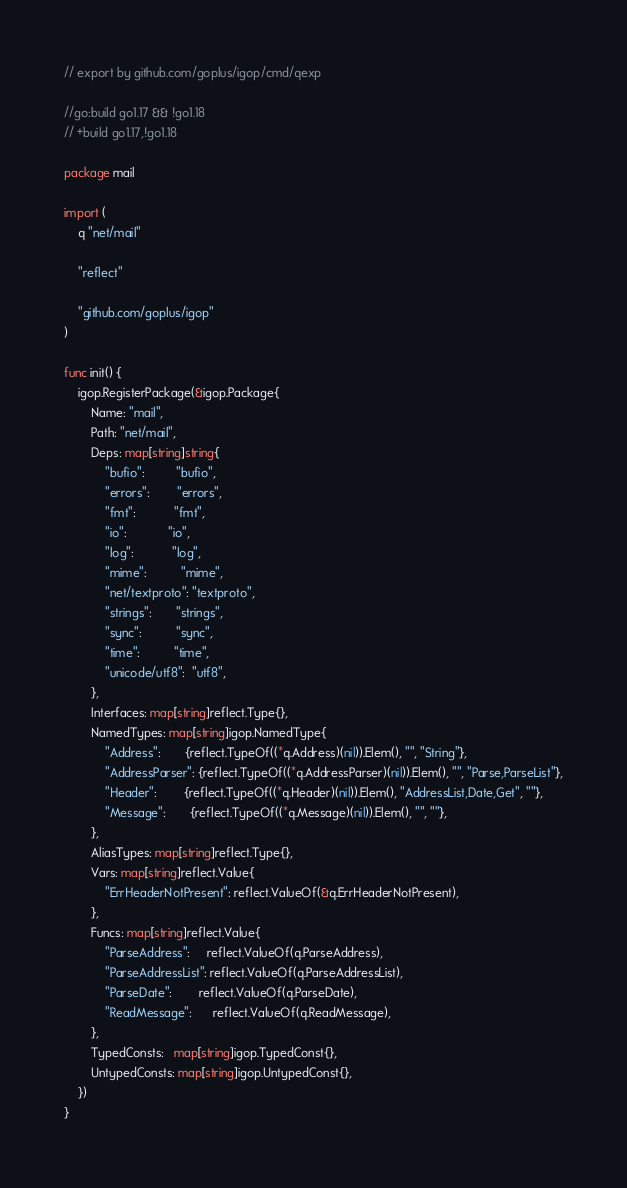Convert code to text. <code><loc_0><loc_0><loc_500><loc_500><_Go_>// export by github.com/goplus/igop/cmd/qexp

//go:build go1.17 && !go1.18
// +build go1.17,!go1.18

package mail

import (
	q "net/mail"

	"reflect"

	"github.com/goplus/igop"
)

func init() {
	igop.RegisterPackage(&igop.Package{
		Name: "mail",
		Path: "net/mail",
		Deps: map[string]string{
			"bufio":         "bufio",
			"errors":        "errors",
			"fmt":           "fmt",
			"io":            "io",
			"log":           "log",
			"mime":          "mime",
			"net/textproto": "textproto",
			"strings":       "strings",
			"sync":          "sync",
			"time":          "time",
			"unicode/utf8":  "utf8",
		},
		Interfaces: map[string]reflect.Type{},
		NamedTypes: map[string]igop.NamedType{
			"Address":       {reflect.TypeOf((*q.Address)(nil)).Elem(), "", "String"},
			"AddressParser": {reflect.TypeOf((*q.AddressParser)(nil)).Elem(), "", "Parse,ParseList"},
			"Header":        {reflect.TypeOf((*q.Header)(nil)).Elem(), "AddressList,Date,Get", ""},
			"Message":       {reflect.TypeOf((*q.Message)(nil)).Elem(), "", ""},
		},
		AliasTypes: map[string]reflect.Type{},
		Vars: map[string]reflect.Value{
			"ErrHeaderNotPresent": reflect.ValueOf(&q.ErrHeaderNotPresent),
		},
		Funcs: map[string]reflect.Value{
			"ParseAddress":     reflect.ValueOf(q.ParseAddress),
			"ParseAddressList": reflect.ValueOf(q.ParseAddressList),
			"ParseDate":        reflect.ValueOf(q.ParseDate),
			"ReadMessage":      reflect.ValueOf(q.ReadMessage),
		},
		TypedConsts:   map[string]igop.TypedConst{},
		UntypedConsts: map[string]igop.UntypedConst{},
	})
}
</code> 